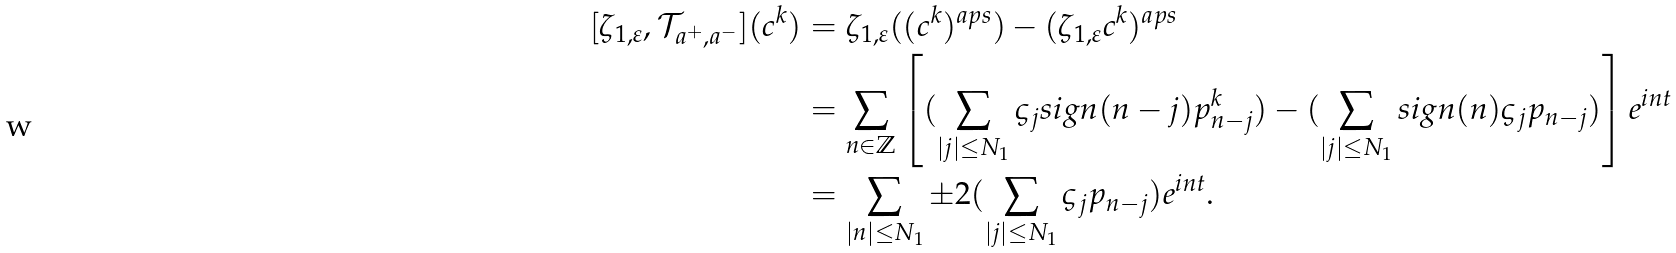Convert formula to latex. <formula><loc_0><loc_0><loc_500><loc_500>[ \zeta _ { 1 , \varepsilon } , \mathcal { T } _ { a ^ { + } , a ^ { - } } ] ( c ^ { k } ) & = \zeta _ { 1 , \varepsilon } ( ( c ^ { k } ) ^ { a p s } ) - ( \zeta _ { 1 , \varepsilon } c ^ { k } ) ^ { a p s } \\ & = \sum _ { n \in \mathbb { Z } } \left [ ( \sum _ { | j | \leq N _ { 1 } } \varsigma _ { j } s i g n ( n - j ) p ^ { k } _ { n - j } ) - ( \sum _ { | j | \leq N _ { 1 } } s i g n ( n ) \varsigma _ { j } p _ { n - j } ) \right ] e ^ { i n t } \\ & = \sum _ { | n | \leq N _ { 1 } } \pm 2 ( \sum _ { | j | \leq N _ { 1 } } \varsigma _ { j } p _ { n - j } ) e ^ { i n t } .</formula> 